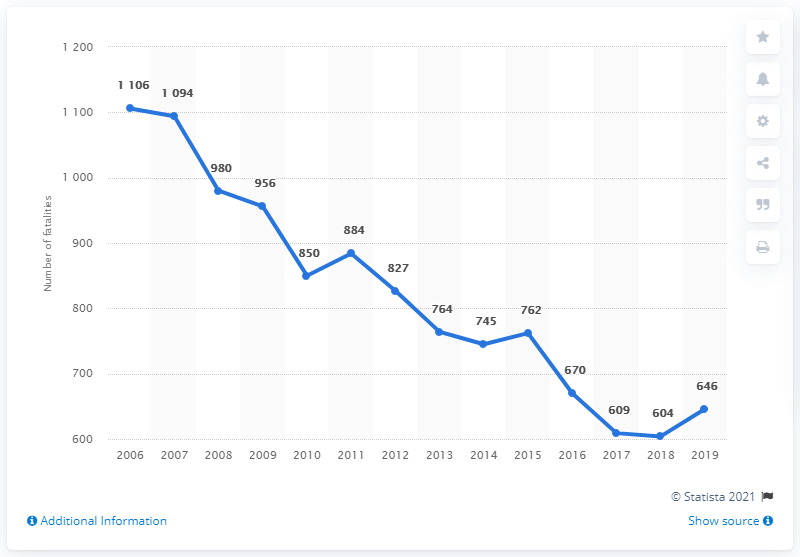Mention a couple of crucial points in this snapshot. The average of the lowest number of fatalities and the highest is 855. The sharpest decline occurred in 2007. In 2011, the number of fatal accidents increased. In 2019, there were 646 road deaths in Belgium. 